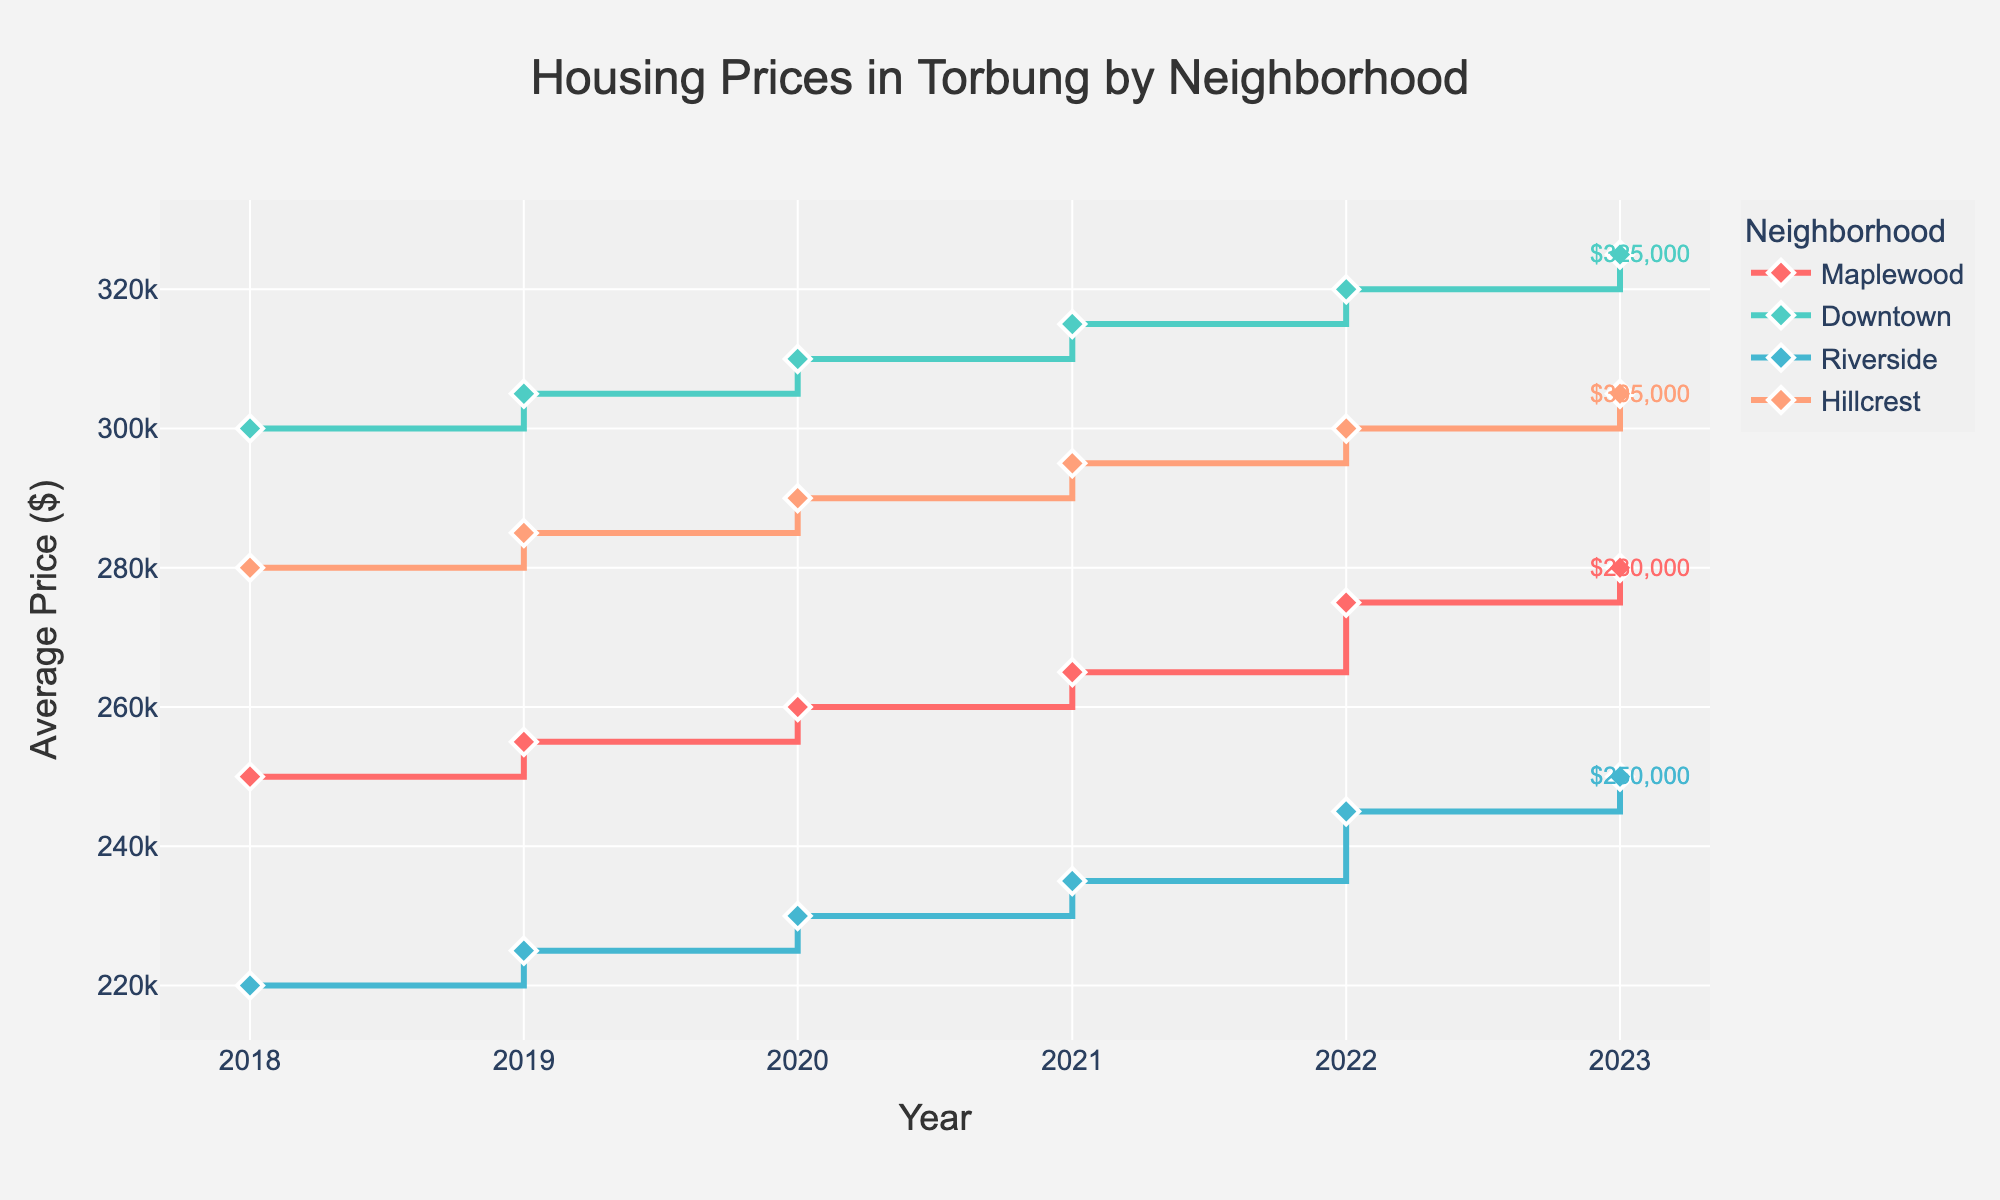What is the title of the plot? The title is a basic element of the plot usually found at the top, indicating the subject of the visualization. In this case, it specifies the contents of the plot.
Answer: Housing Prices in Torbung by Neighborhood How many neighborhoods are represented in the plot? By examining the legend, we can count the distinct colors and labels assigned to each neighborhood.
Answer: 4 Which neighborhood had the highest average housing price in 2023? By looking at the endpoints of the lines for the year 2023 and comparing their values, we can identify the highest one. Downtown's line ends at the highest price point.
Answer: Downtown How did the average price in Maplewood change from 2018 to 2023? Calculate the difference between the average prices for Maplewood in 2023 and 2018 by observing the starting and ending points of Maplewood's line.
Answer: Increased by 30,000 Which neighborhood showed the largest price increase from 2018 to 2023? For each neighborhood, subtract the 2018 average price from the 2023 average price, and identify the largest result. Downtown's price increased from 300,000 to 325,000, which is the highest increase.
Answer: Downtown By how much did Riverside's average price change each year on average from 2018 to 2023? Calculate the total change in Riverside's price from 2018 to 2023, then divide by the number of years (5 years). (250,000 - 220,000) / 5 = 6,000
Answer: 6,000 per year In which year did Hillcrest and Riverside both have the same average price? By examining the plot, we can see if there are any points where the lines for Hillcrest and Riverside intersect. They do not intersect in any year, hence there is no such year.
Answer: None Which neighborhood had the most stable housing prices over the period 2018 to 2023? The stability can be interpreted by the smallest absolute difference in price from the initial year to final year. Riverside’s prices had the smallest variation (250,000 - 220,000).
Answer: Riverside Compare the housing price trend of Maplewood and Hillcrest from 2018 to 2023. Observe and describe the lines for Maplewood and Hillcrest. Both neighborhoods show a steady increase, but Hillcrest started higher and ended higher compared to Maplewood.
Answer: Both increased, but Hillcrest stayed higher What is the general trend of housing prices in Torbung from 2018 to 2023? By observing the lines for all neighborhoods, it can be generalized if the trend is increasing, decreasing, or stable. All neighborhoods have increasing lines, indicating an overall increase.
Answer: Increasing 